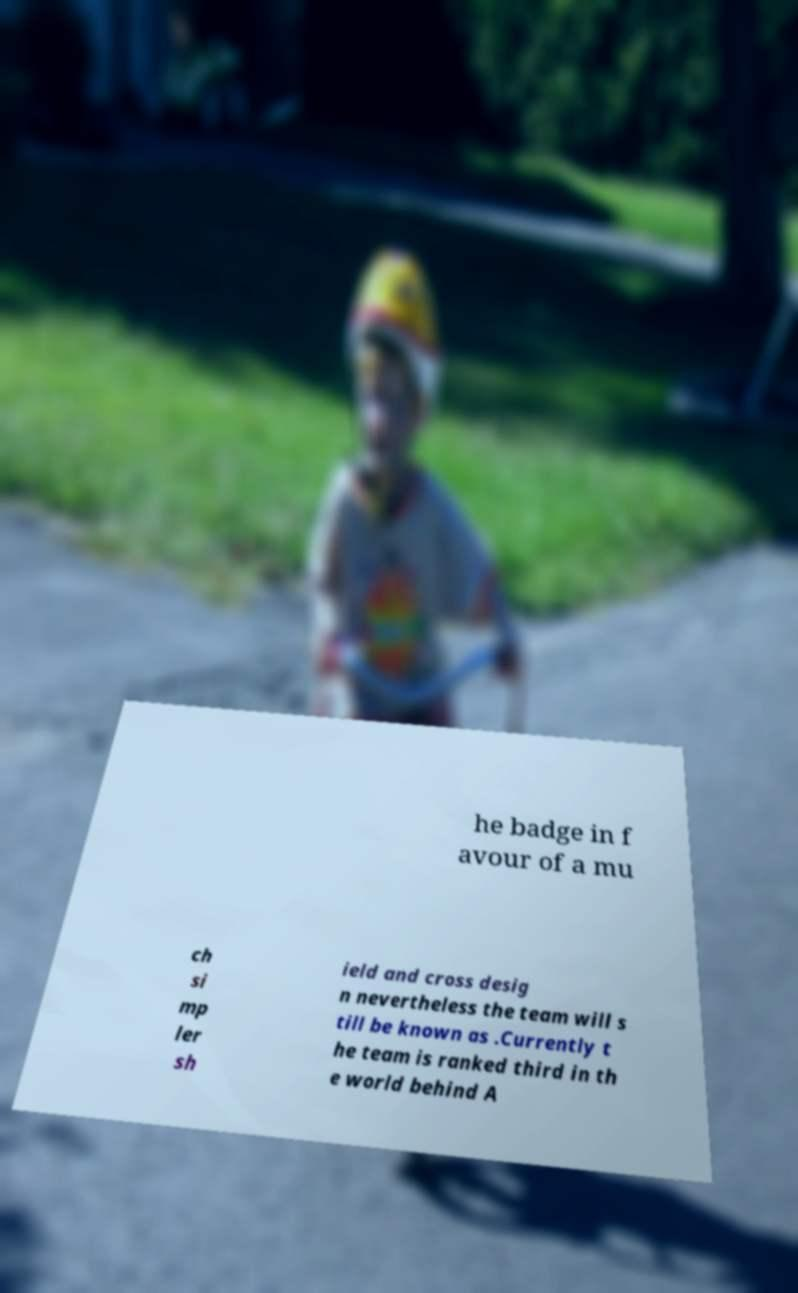Could you extract and type out the text from this image? he badge in f avour of a mu ch si mp ler sh ield and cross desig n nevertheless the team will s till be known as .Currently t he team is ranked third in th e world behind A 